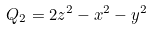Convert formula to latex. <formula><loc_0><loc_0><loc_500><loc_500>Q _ { 2 } = 2 z ^ { 2 } - x ^ { 2 } - y ^ { 2 }</formula> 